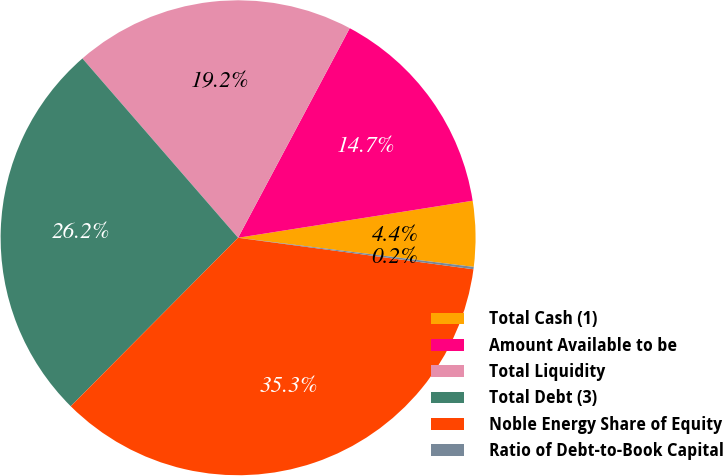<chart> <loc_0><loc_0><loc_500><loc_500><pie_chart><fcel>Total Cash (1)<fcel>Amount Available to be<fcel>Total Liquidity<fcel>Total Debt (3)<fcel>Noble Energy Share of Equity<fcel>Ratio of Debt-to-Book Capital<nl><fcel>4.45%<fcel>14.72%<fcel>19.17%<fcel>26.18%<fcel>35.33%<fcel>0.16%<nl></chart> 